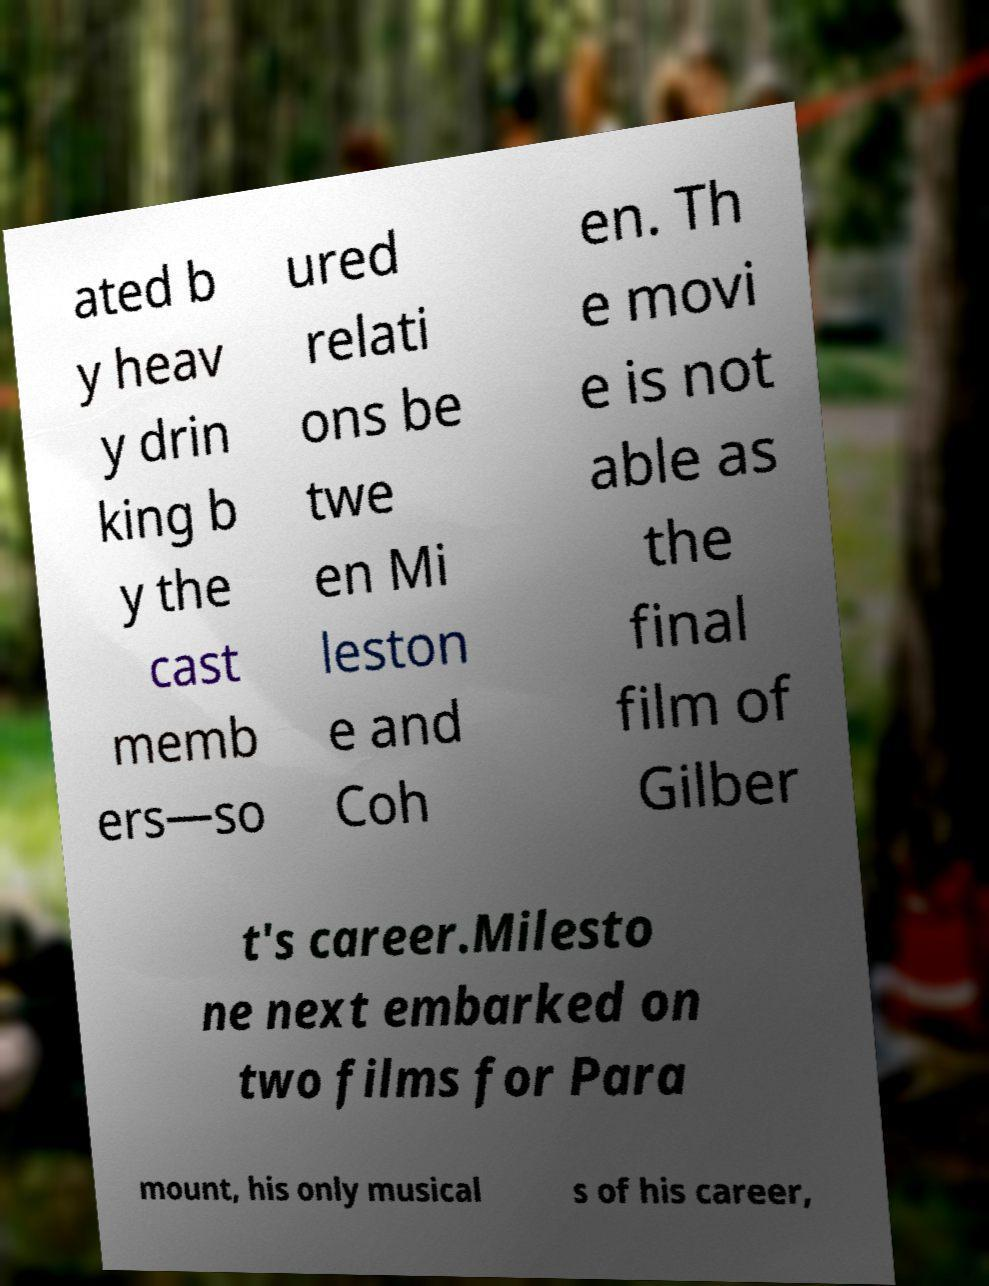Can you read and provide the text displayed in the image?This photo seems to have some interesting text. Can you extract and type it out for me? ated b y heav y drin king b y the cast memb ers—so ured relati ons be twe en Mi leston e and Coh en. Th e movi e is not able as the final film of Gilber t's career.Milesto ne next embarked on two films for Para mount, his only musical s of his career, 